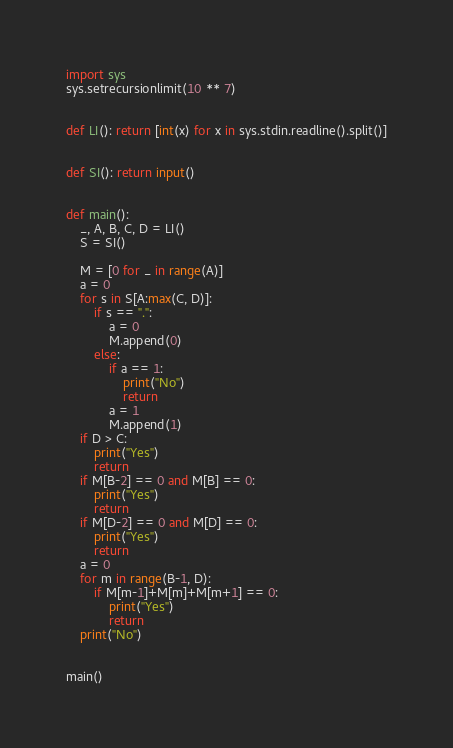Convert code to text. <code><loc_0><loc_0><loc_500><loc_500><_Python_>import sys
sys.setrecursionlimit(10 ** 7)


def LI(): return [int(x) for x in sys.stdin.readline().split()]


def SI(): return input()


def main():
    _, A, B, C, D = LI()
    S = SI()

    M = [0 for _ in range(A)]
    a = 0
    for s in S[A:max(C, D)]:
        if s == ".":
            a = 0
            M.append(0)
        else:
            if a == 1:
                print("No")
                return
            a = 1
            M.append(1)
    if D > C:
        print("Yes")
        return
    if M[B-2] == 0 and M[B] == 0:
        print("Yes")
        return
    if M[D-2] == 0 and M[D] == 0:
        print("Yes")
        return
    a = 0
    for m in range(B-1, D):
        if M[m-1]+M[m]+M[m+1] == 0:
            print("Yes")
            return
    print("No")


main()
</code> 